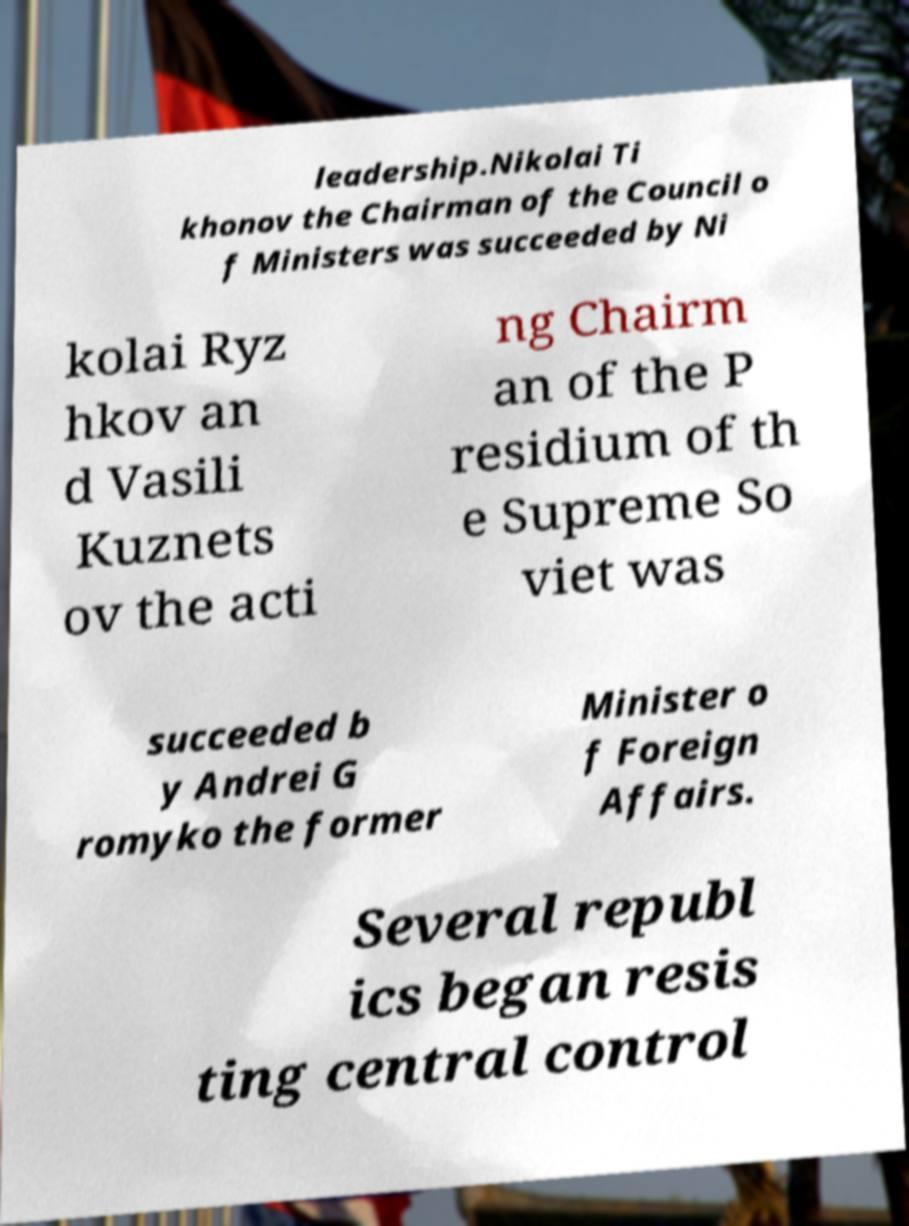Could you extract and type out the text from this image? leadership.Nikolai Ti khonov the Chairman of the Council o f Ministers was succeeded by Ni kolai Ryz hkov an d Vasili Kuznets ov the acti ng Chairm an of the P residium of th e Supreme So viet was succeeded b y Andrei G romyko the former Minister o f Foreign Affairs. Several republ ics began resis ting central control 